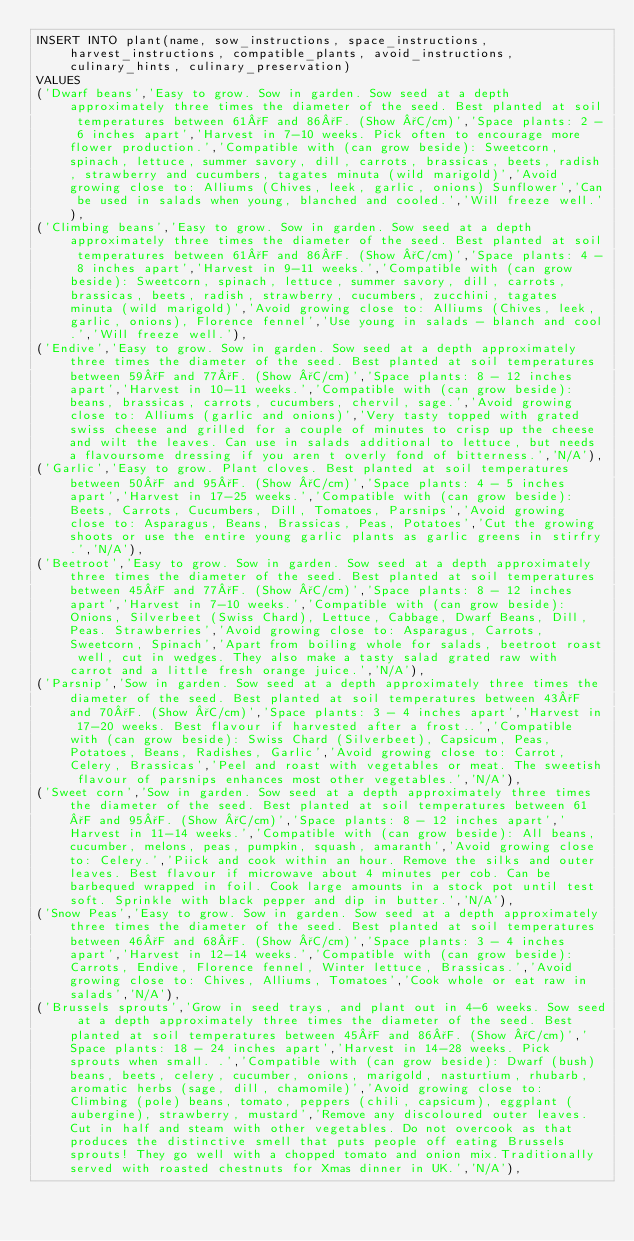<code> <loc_0><loc_0><loc_500><loc_500><_SQL_>INSERT INTO plant(name, sow_instructions, space_instructions, harvest_instructions, compatible_plants, avoid_instructions, culinary_hints, culinary_preservation)
VALUES
('Dwarf beans','Easy to grow. Sow in garden. Sow seed at a depth approximately three times the diameter of the seed. Best planted at soil temperatures between 61°F and 86°F. (Show °C/cm)','Space plants: 2 - 6 inches apart','Harvest in 7-10 weeks. Pick often to encourage more flower production.','Compatible with (can grow beside): Sweetcorn, spinach, lettuce, summer savory, dill, carrots, brassicas, beets, radish, strawberry and cucumbers, tagates minuta (wild marigold)','Avoid growing close to: Alliums (Chives, leek, garlic, onions) Sunflower','Can be used in salads when young, blanched and cooled.','Will freeze well.'),
('Climbing beans','Easy to grow. Sow in garden. Sow seed at a depth approximately three times the diameter of the seed. Best planted at soil temperatures between 61°F and 86°F. (Show °C/cm)','Space plants: 4 - 8 inches apart','Harvest in 9-11 weeks.','Compatible with (can grow beside): Sweetcorn, spinach, lettuce, summer savory, dill, carrots, brassicas, beets, radish, strawberry, cucumbers, zucchini, tagates minuta (wild marigold)','Avoid growing close to: Alliums (Chives, leek, garlic, onions), Florence fennel','Use young in salads - blanch and cool.','Will freeze well.'),
('Endive','Easy to grow. Sow in garden. Sow seed at a depth approximately three times the diameter of the seed. Best planted at soil temperatures between 59°F and 77°F. (Show °C/cm)','Space plants: 8 - 12 inches apart','Harvest in 10-11 weeks.','Compatible with (can grow beside): beans, brassicas, carrots, cucumbers, chervil, sage.','Avoid growing close to: Alliums (garlic and onions)','Very tasty topped with grated swiss cheese and grilled for a couple of minutes to crisp up the cheese and wilt the leaves. Can use in salads additional to lettuce, but needs a flavoursome dressing if you aren t overly fond of bitterness.','N/A'),
('Garlic','Easy to grow. Plant cloves. Best planted at soil temperatures between 50°F and 95°F. (Show °C/cm)','Space plants: 4 - 5 inches apart','Harvest in 17-25 weeks.','Compatible with (can grow beside): Beets, Carrots, Cucumbers, Dill, Tomatoes, Parsnips','Avoid growing close to: Asparagus, Beans, Brassicas, Peas, Potatoes','Cut the growing shoots or use the entire young garlic plants as garlic greens in stirfry.','N/A'),
('Beetroot','Easy to grow. Sow in garden. Sow seed at a depth approximately three times the diameter of the seed. Best planted at soil temperatures between 45°F and 77°F. (Show °C/cm)','Space plants: 8 - 12 inches apart','Harvest in 7-10 weeks.','Compatible with (can grow beside): Onions, Silverbeet (Swiss Chard), Lettuce, Cabbage, Dwarf Beans, Dill, Peas. Strawberries','Avoid growing close to: Asparagus, Carrots, Sweetcorn, Spinach','Apart from boiling whole for salads, beetroot roast well, cut in wedges. They also make a tasty salad grated raw with carrot and a little fresh orange juice.','N/A'),
('Parsnip','Sow in garden. Sow seed at a depth approximately three times the diameter of the seed. Best planted at soil temperatures between 43°F and 70°F. (Show °C/cm)','Space plants: 3 - 4 inches apart','Harvest in 17-20 weeks. Best flavour if harvested after a frost..','Compatible with (can grow beside): Swiss Chard (Silverbeet), Capsicum, Peas, Potatoes, Beans, Radishes, Garlic','Avoid growing close to: Carrot, Celery, Brassicas','Peel and roast with vegetables or meat. The sweetish flavour of parsnips enhances most other vegetables.','N/A'),
('Sweet corn','Sow in garden. Sow seed at a depth approximately three times the diameter of the seed. Best planted at soil temperatures between 61°F and 95°F. (Show °C/cm)','Space plants: 8 - 12 inches apart','Harvest in 11-14 weeks.','Compatible with (can grow beside): All beans, cucumber, melons, peas, pumpkin, squash, amaranth','Avoid growing close to: Celery.','Piick and cook within an hour. Remove the silks and outer leaves. Best flavour if microwave about 4 minutes per cob. Can be barbequed wrapped in foil. Cook large amounts in a stock pot until test soft. Sprinkle with black pepper and dip in butter.','N/A'),
('Snow Peas','Easy to grow. Sow in garden. Sow seed at a depth approximately three times the diameter of the seed. Best planted at soil temperatures between 46°F and 68°F. (Show °C/cm)','Space plants: 3 - 4 inches apart','Harvest in 12-14 weeks.','Compatible with (can grow beside): Carrots, Endive, Florence fennel, Winter lettuce, Brassicas.','Avoid growing close to: Chives, Alliums, Tomatoes','Cook whole or eat raw in salads','N/A'),
('Brussels sprouts','Grow in seed trays, and plant out in 4-6 weeks. Sow seed at a depth approximately three times the diameter of the seed. Best planted at soil temperatures between 45°F and 86°F. (Show °C/cm)','Space plants: 18 - 24 inches apart','Harvest in 14-28 weeks. Pick sprouts when small. .','Compatible with (can grow beside): Dwarf (bush) beans, beets, celery, cucumber, onions, marigold, nasturtium, rhubarb, aromatic herbs (sage, dill, chamomile)','Avoid growing close to: Climbing (pole) beans, tomato, peppers (chili, capsicum), eggplant (aubergine), strawberry, mustard','Remove any discoloured outer leaves. Cut in half and steam with other vegetables. Do not overcook as that produces the distinctive smell that puts people off eating Brussels sprouts! They go well with a chopped tomato and onion mix.Traditionally served with roasted chestnuts for Xmas dinner in UK.','N/A'),</code> 